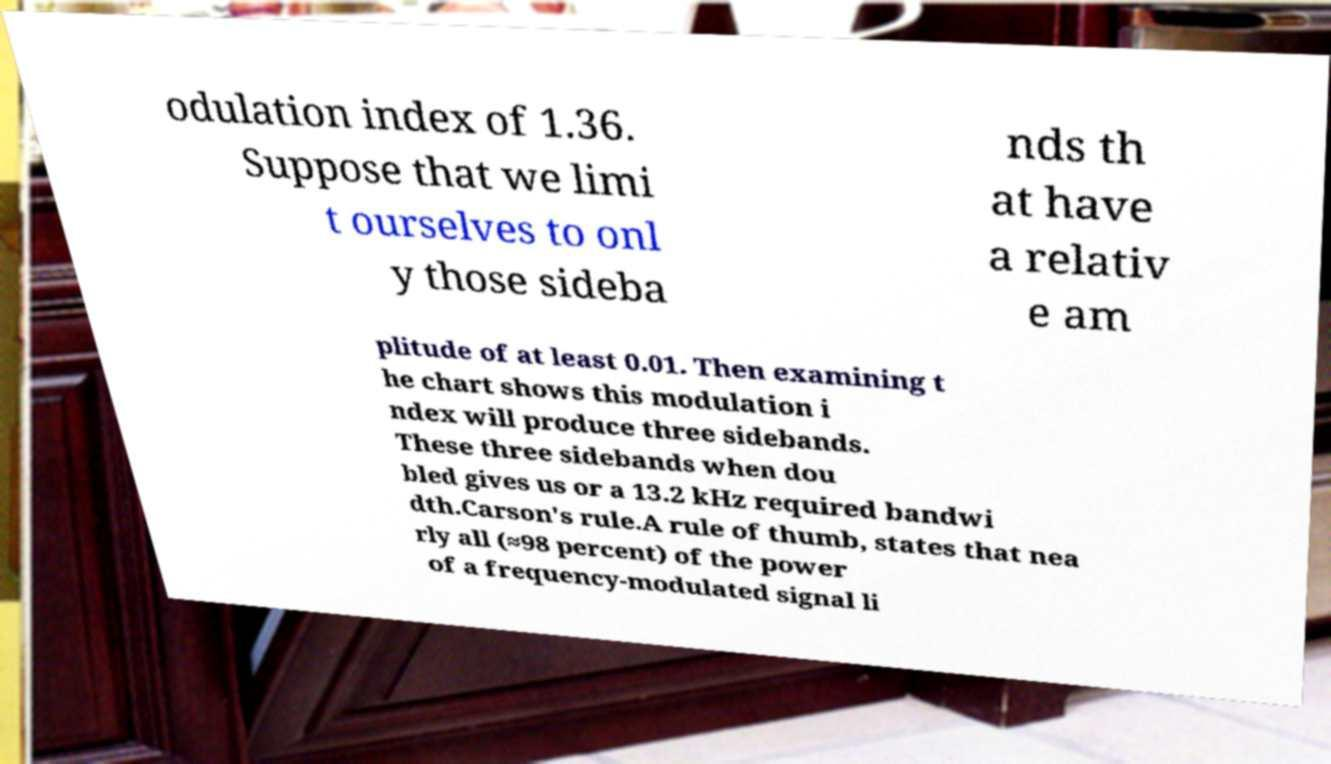Can you accurately transcribe the text from the provided image for me? odulation index of 1.36. Suppose that we limi t ourselves to onl y those sideba nds th at have a relativ e am plitude of at least 0.01. Then examining t he chart shows this modulation i ndex will produce three sidebands. These three sidebands when dou bled gives us or a 13.2 kHz required bandwi dth.Carson's rule.A rule of thumb, states that nea rly all (≈98 percent) of the power of a frequency-modulated signal li 